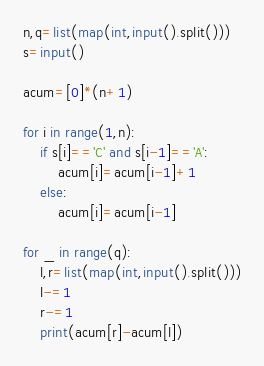<code> <loc_0><loc_0><loc_500><loc_500><_Python_>n,q=list(map(int,input().split()))
s=input()

acum=[0]*(n+1)

for i in range(1,n):
    if s[i]=='C' and s[i-1]=='A':
        acum[i]=acum[i-1]+1
    else:
        acum[i]=acum[i-1]

for _ in range(q):
    l,r=list(map(int,input().split()))
    l-=1
    r-=1
    print(acum[r]-acum[l])</code> 